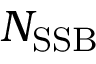<formula> <loc_0><loc_0><loc_500><loc_500>N _ { S S B }</formula> 